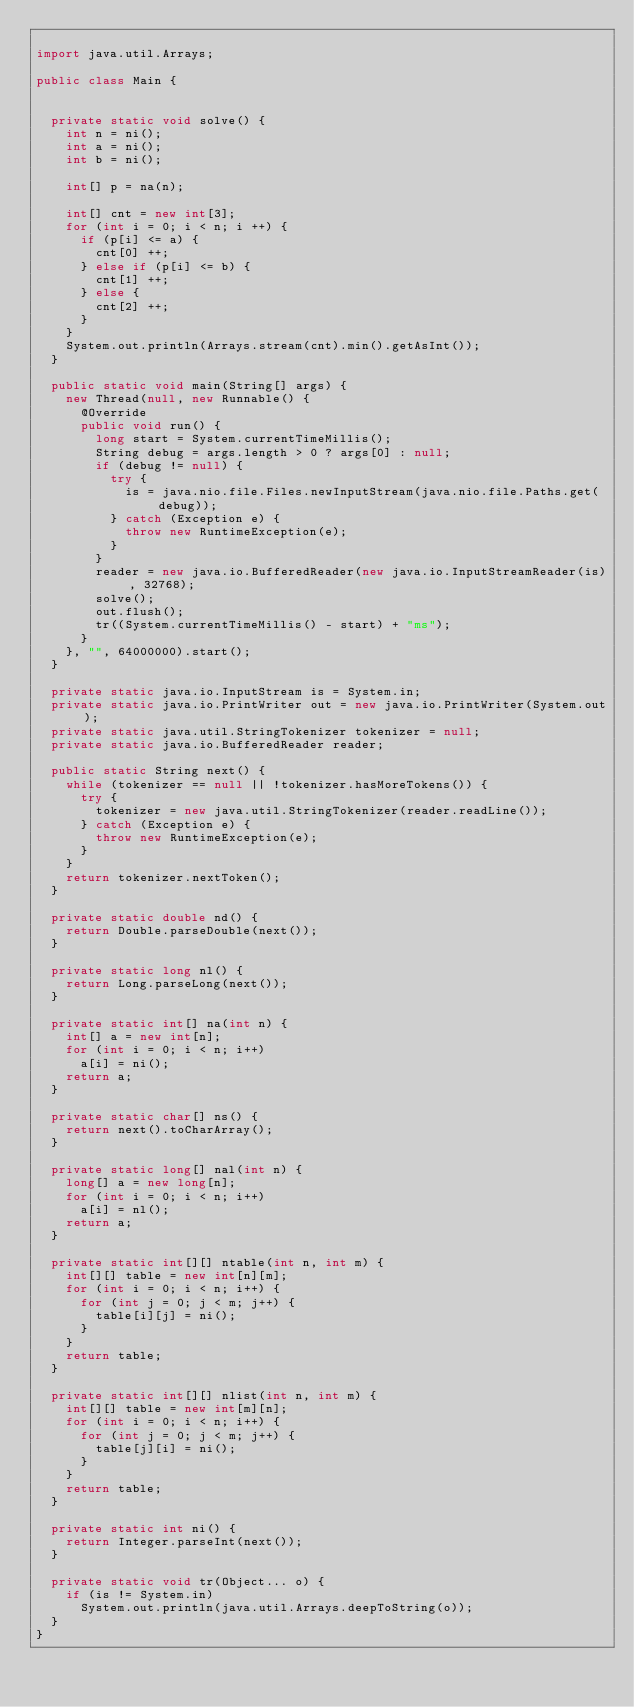Convert code to text. <code><loc_0><loc_0><loc_500><loc_500><_Java_>
import java.util.Arrays;

public class Main {


  private static void solve() {
    int n = ni();
    int a = ni();
    int b = ni();
    
    int[] p = na(n);
    
    int[] cnt = new int[3];
    for (int i = 0; i < n; i ++) {
      if (p[i] <= a) {
        cnt[0] ++;
      } else if (p[i] <= b) {
        cnt[1] ++;
      } else {
        cnt[2] ++;
      }
    }
    System.out.println(Arrays.stream(cnt).min().getAsInt());
  }

  public static void main(String[] args) {
    new Thread(null, new Runnable() {
      @Override
      public void run() {
        long start = System.currentTimeMillis();
        String debug = args.length > 0 ? args[0] : null;
        if (debug != null) {
          try {
            is = java.nio.file.Files.newInputStream(java.nio.file.Paths.get(debug));
          } catch (Exception e) {
            throw new RuntimeException(e);
          }
        }
        reader = new java.io.BufferedReader(new java.io.InputStreamReader(is), 32768);
        solve();
        out.flush();
        tr((System.currentTimeMillis() - start) + "ms");
      }
    }, "", 64000000).start();
  }

  private static java.io.InputStream is = System.in;
  private static java.io.PrintWriter out = new java.io.PrintWriter(System.out);
  private static java.util.StringTokenizer tokenizer = null;
  private static java.io.BufferedReader reader;

  public static String next() {
    while (tokenizer == null || !tokenizer.hasMoreTokens()) {
      try {
        tokenizer = new java.util.StringTokenizer(reader.readLine());
      } catch (Exception e) {
        throw new RuntimeException(e);
      }
    }
    return tokenizer.nextToken();
  }

  private static double nd() {
    return Double.parseDouble(next());
  }

  private static long nl() {
    return Long.parseLong(next());
  }

  private static int[] na(int n) {
    int[] a = new int[n];
    for (int i = 0; i < n; i++)
      a[i] = ni();
    return a;
  }

  private static char[] ns() {
    return next().toCharArray();
  }

  private static long[] nal(int n) {
    long[] a = new long[n];
    for (int i = 0; i < n; i++)
      a[i] = nl();
    return a;
  }

  private static int[][] ntable(int n, int m) {
    int[][] table = new int[n][m];
    for (int i = 0; i < n; i++) {
      for (int j = 0; j < m; j++) {
        table[i][j] = ni();
      }
    }
    return table;
  }

  private static int[][] nlist(int n, int m) {
    int[][] table = new int[m][n];
    for (int i = 0; i < n; i++) {
      for (int j = 0; j < m; j++) {
        table[j][i] = ni();
      }
    }
    return table;
  }

  private static int ni() {
    return Integer.parseInt(next());
  }

  private static void tr(Object... o) {
    if (is != System.in)
      System.out.println(java.util.Arrays.deepToString(o));
  }
}
</code> 